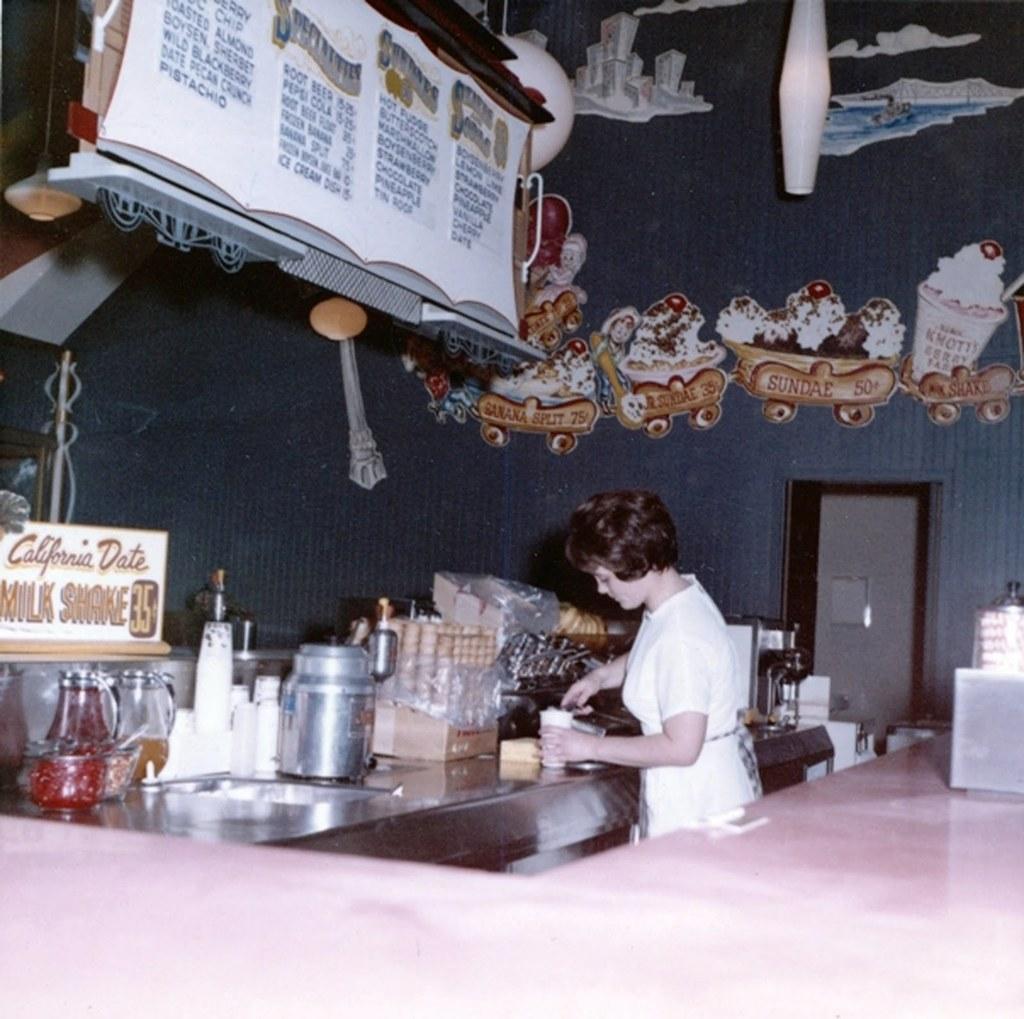Can you describe this image briefly? In the picture we can see a woman standing near the desk and preparing something. On the desk we can find a bottles, jars, cups and something items, in the background we can find wall and door. 